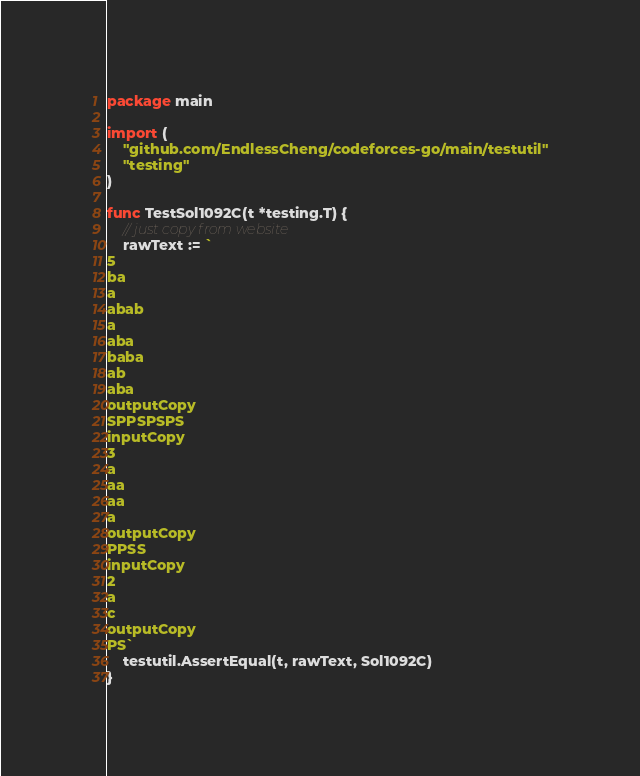Convert code to text. <code><loc_0><loc_0><loc_500><loc_500><_Go_>package main

import (
	"github.com/EndlessCheng/codeforces-go/main/testutil"
	"testing"
)

func TestSol1092C(t *testing.T) {
	// just copy from website
	rawText := `
5
ba
a
abab
a
aba
baba
ab
aba
outputCopy
SPPSPSPS
inputCopy
3
a
aa
aa
a
outputCopy
PPSS
inputCopy
2
a
c
outputCopy
PS`
	testutil.AssertEqual(t, rawText, Sol1092C)
}
</code> 